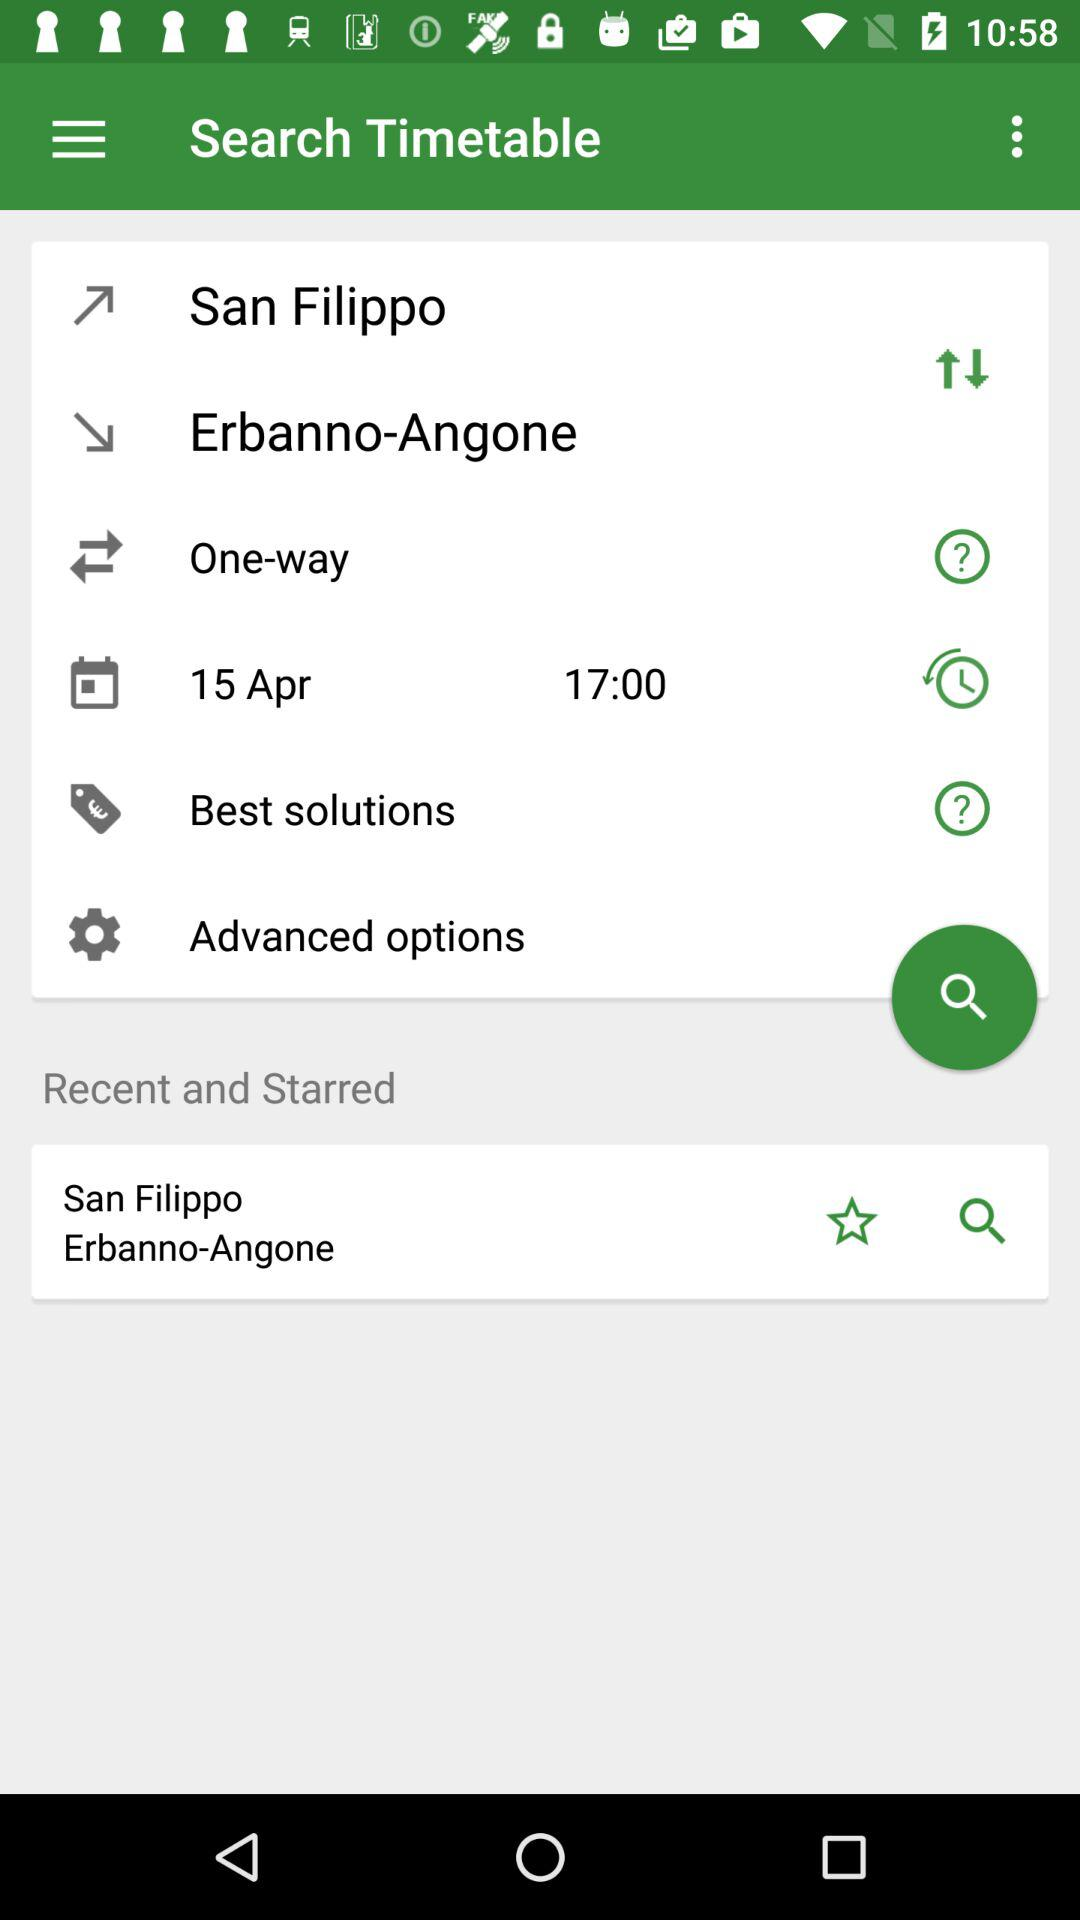What's the shown date? The shown date is April 15. 